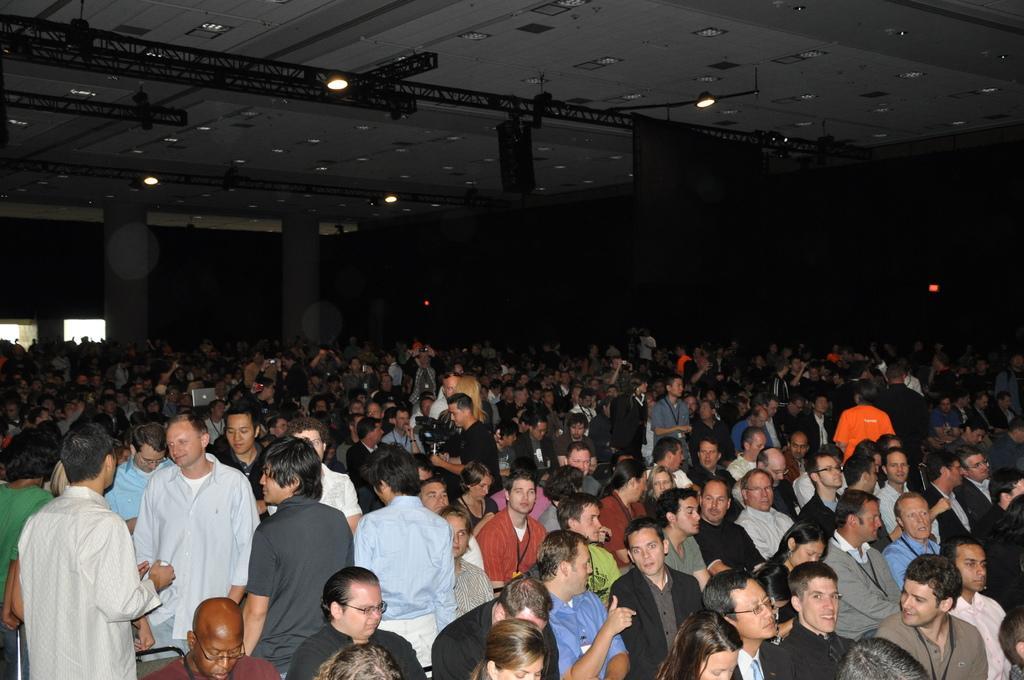How would you summarize this image in a sentence or two? As we can see in the image there are group of people here and there. Few of them are standing and few of them are sitting on chairs. There are lights, wall and windows. 